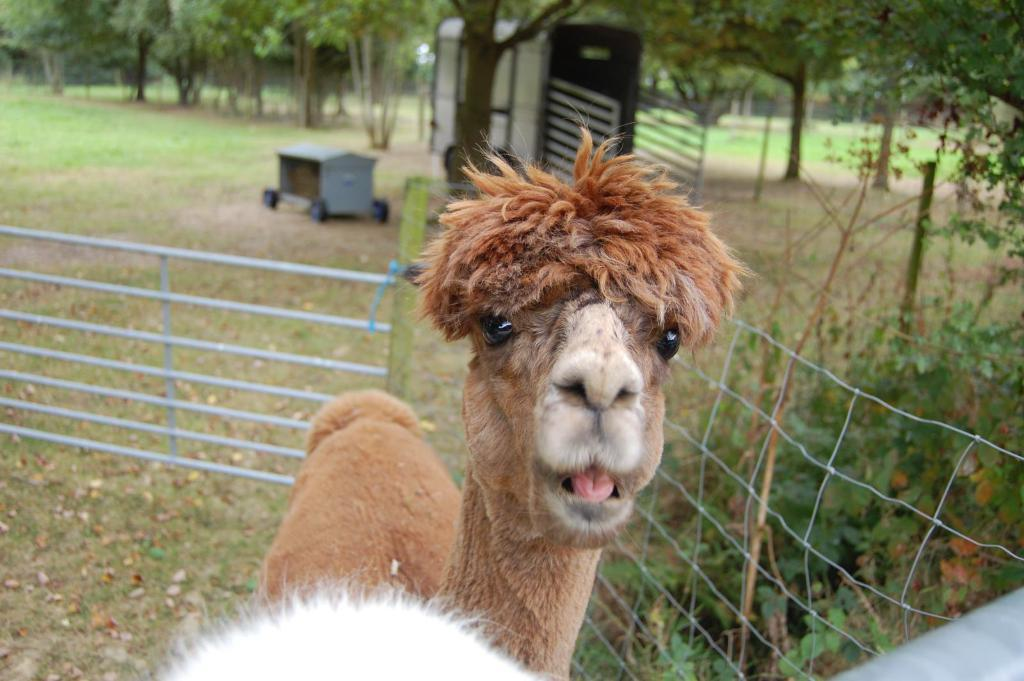What type of animal can be seen in the image? There is an animal in the image, but the specific type cannot be determined from the provided facts. What type of vegetation is present in the image? There is grass in the image, and a group of trees is visible in the background. What structures are present in the image? There is a fence, a pole, and a trolley in the image. What is the ground surface like in the image? The ground surface is not explicitly described, but a truck is on the ground in the image. What part of a tree is visible in the image? The bark of a tree is visible in the image. Can you recall any memories of the seashore in the image? There is no mention of a seashore in the image, so it cannot be used as a reference point for recalling memories. What feelings of regret can be observed in the image? There is no indication of regret in the image, as it primarily features an animal, grass, a fence, a pole, a trolley, tree bark, a truck, and a group of trees in the background. 